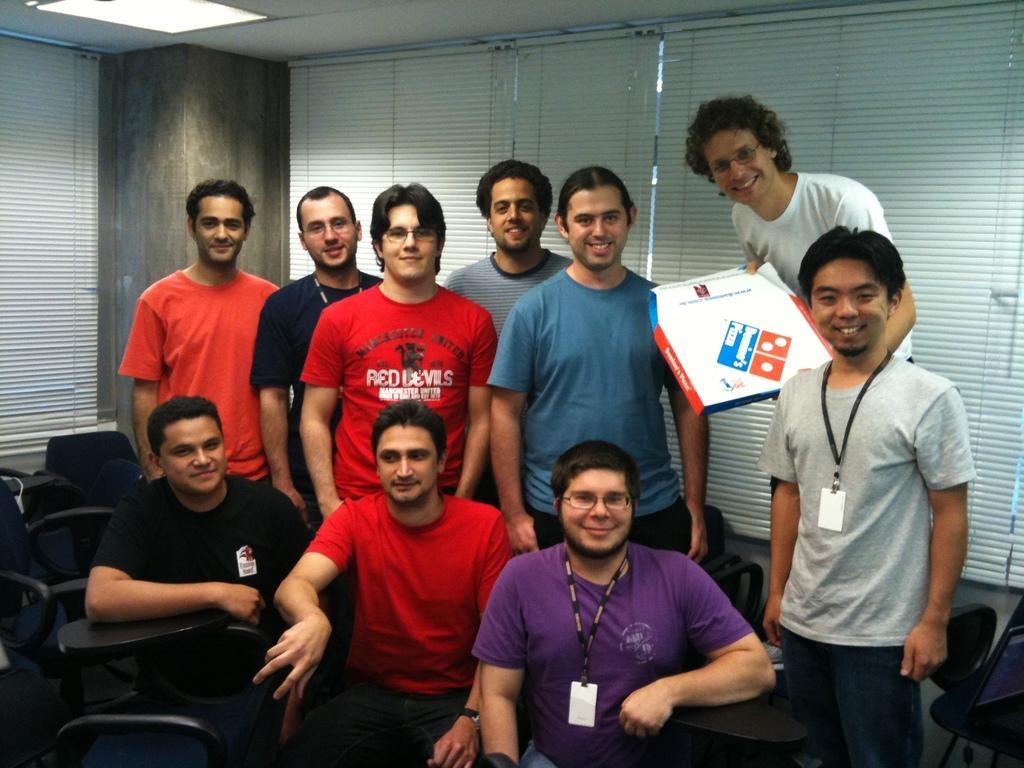Could you give a brief overview of what you see in this image? In this image I can see number of people where in the front I can see few are sitting and in the background I can see all of them are standing. On the right side I can see one man is holding a box. In the background I can see window blinds and on the top left side of this image I can see a light. 